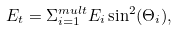<formula> <loc_0><loc_0><loc_500><loc_500>E _ { t } = \Sigma _ { i = 1 } ^ { m u l t } E _ { i } \sin ^ { 2 } ( \Theta _ { i } ) ,</formula> 